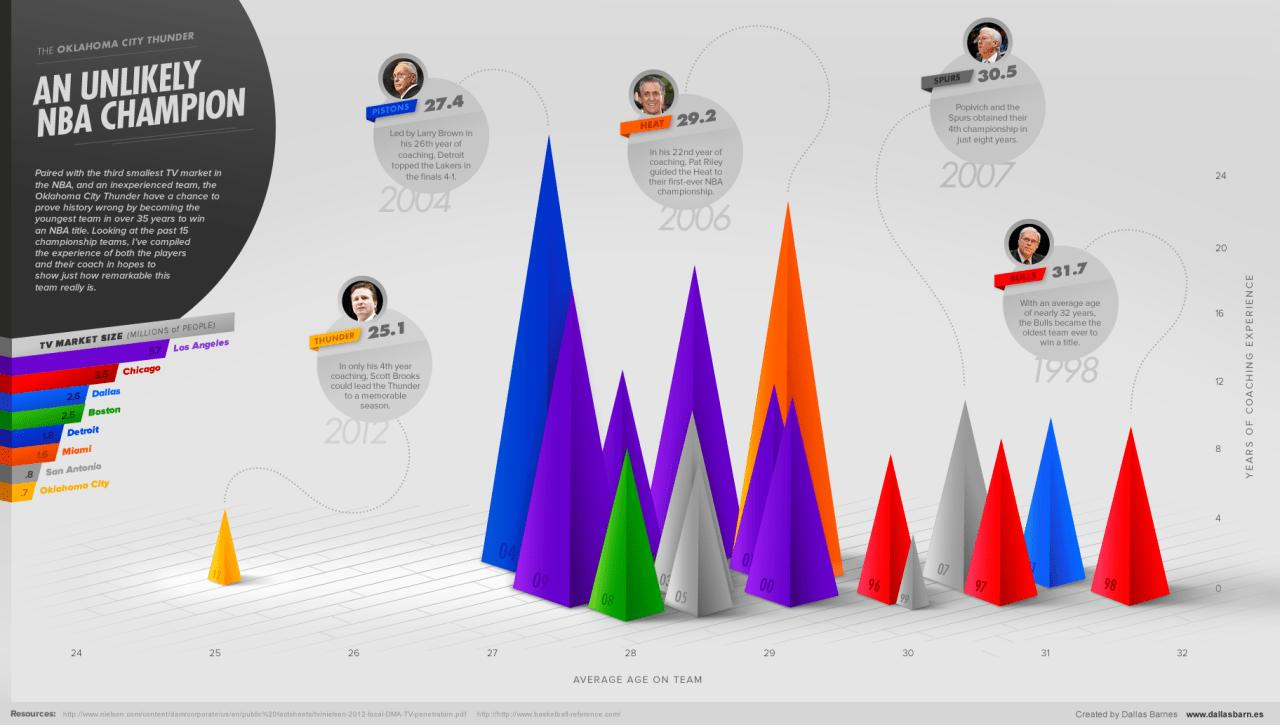Draw attention to some important aspects in this diagram. The three NBA teams with the highest TV market are Los Angeles, Chicago, and Dallas. The team with the highest average age is the Bulls. The Miami Heat, San Antonio Spurs, and Oklahoma City Thunder are the three NBA teams with the lowest TV market. The coach of Spurs was Popivich. The Oklahoma City Thunder is the youngest team. 